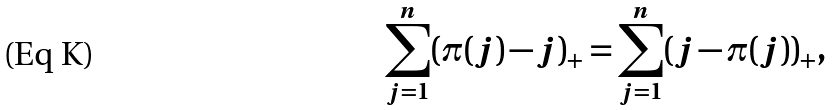<formula> <loc_0><loc_0><loc_500><loc_500>\sum _ { j = 1 } ^ { n } ( \pi ( j ) - j ) _ { + } = \sum _ { j = 1 } ^ { n } ( j - \pi ( j ) ) _ { + } ,</formula> 